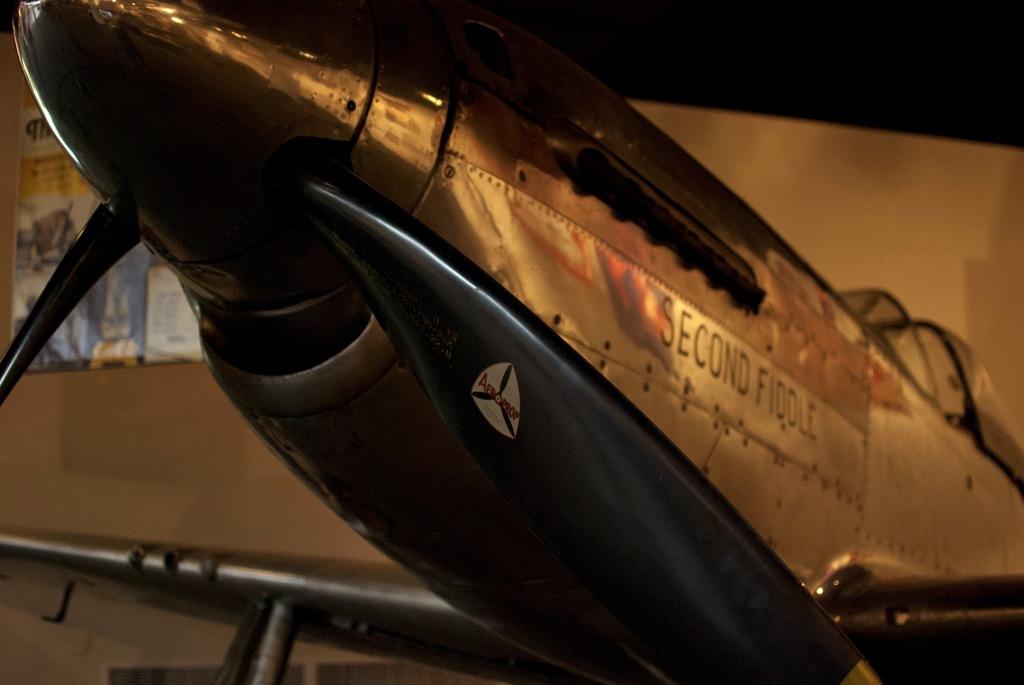What it is?
Keep it short and to the point. Second fiddle. 